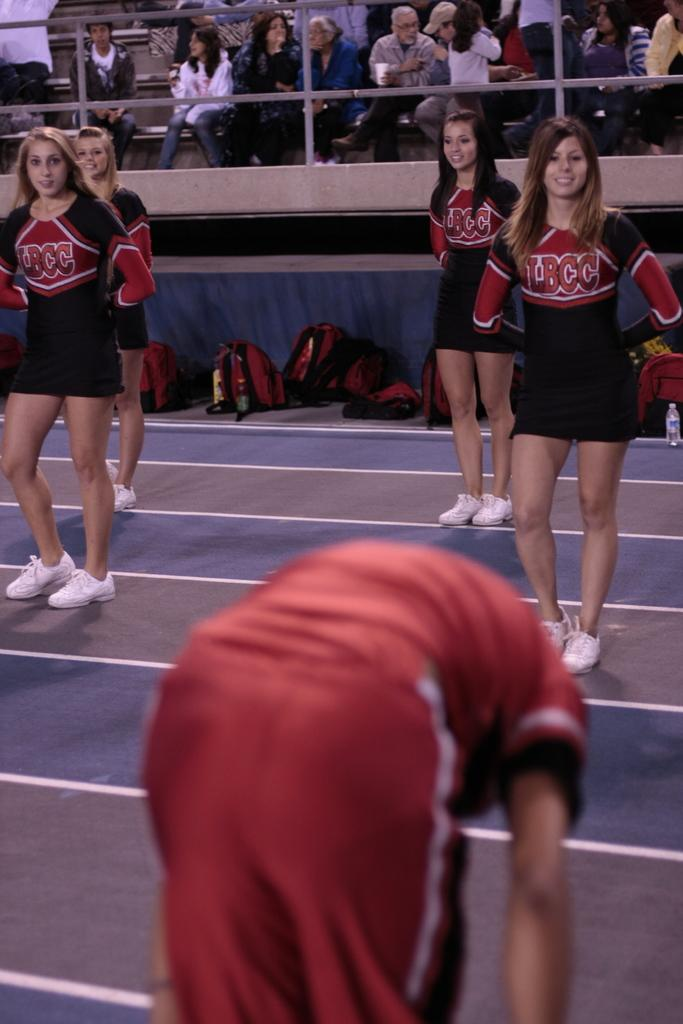<image>
Write a terse but informative summary of the picture. Cheerleaders from LBCC stand ready to cheer, while an athlete stretches in front of them. 